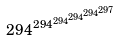Convert formula to latex. <formula><loc_0><loc_0><loc_500><loc_500>2 9 4 ^ { 2 9 4 ^ { 2 9 4 ^ { 2 9 4 ^ { 2 9 4 ^ { 2 9 7 } } } } }</formula> 